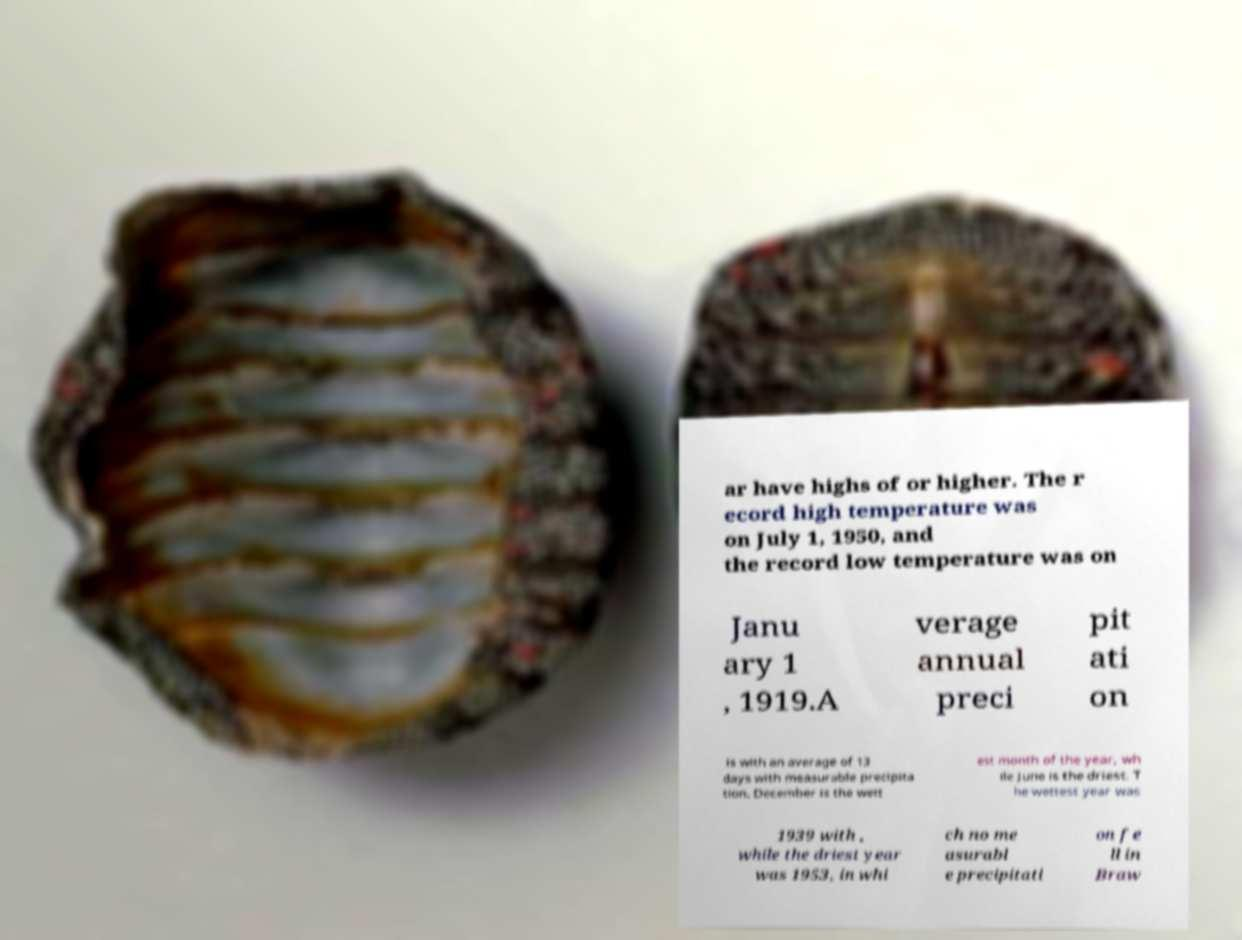Please identify and transcribe the text found in this image. ar have highs of or higher. The r ecord high temperature was on July 1, 1950, and the record low temperature was on Janu ary 1 , 1919.A verage annual preci pit ati on is with an average of 13 days with measurable precipita tion. December is the wett est month of the year, wh ile June is the driest. T he wettest year was 1939 with , while the driest year was 1953, in whi ch no me asurabl e precipitati on fe ll in Braw 